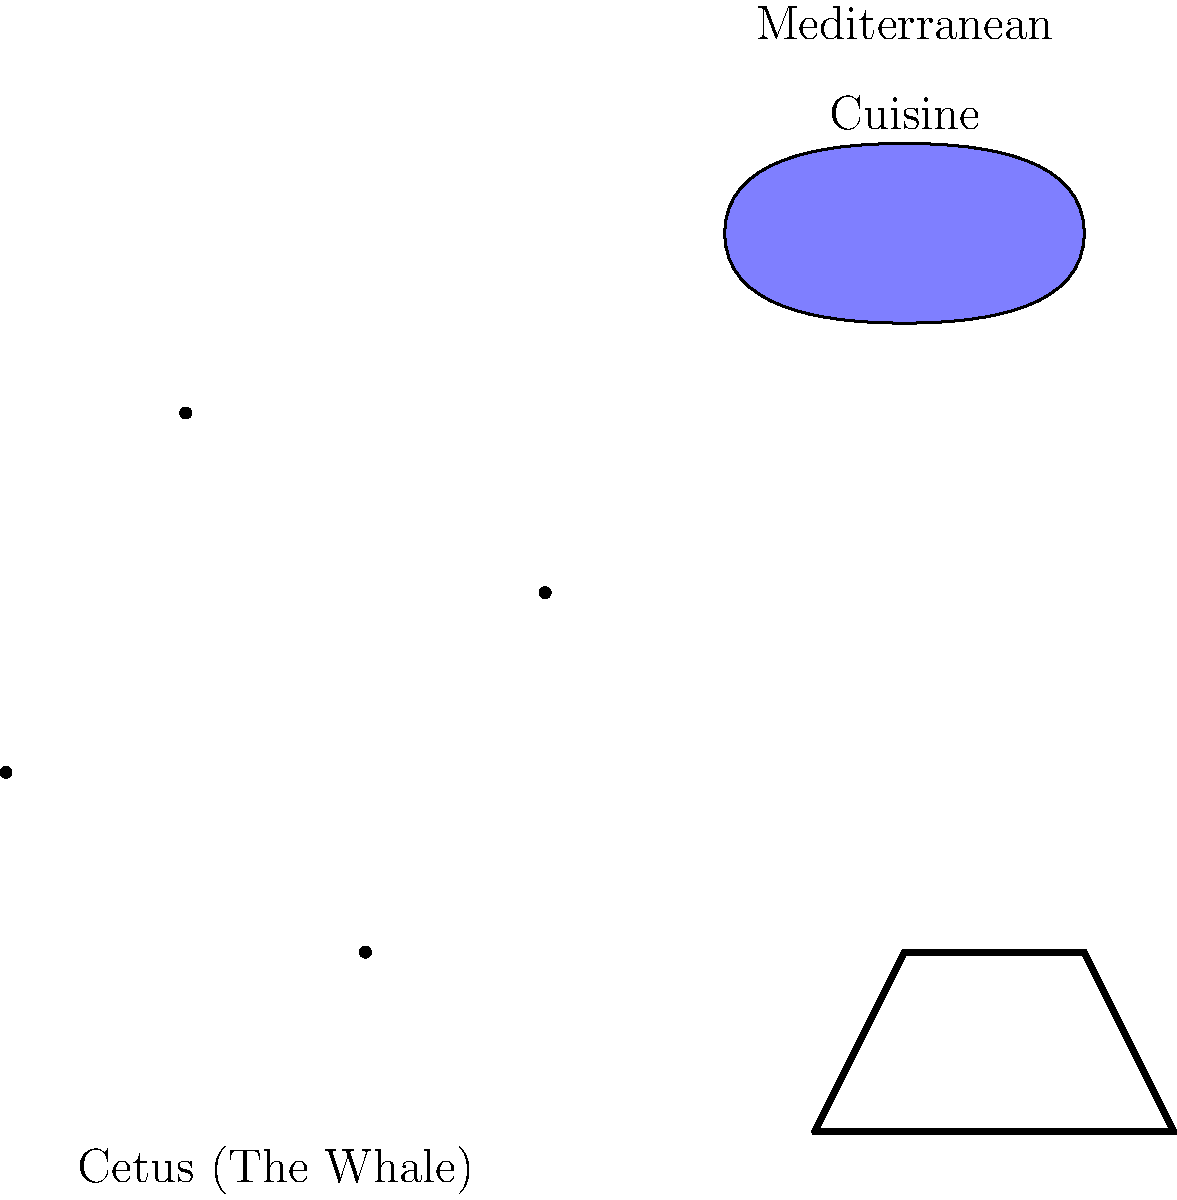Which constellation, associated with Mediterranean cuisine and often depicted alongside fish symbols, is shown in the image, and what culinary tradition does it represent? To answer this question, let's break down the information provided in the image:

1. The main constellation shape is labeled as "Cetus (The Whale)".
2. There's a stylized fish drawn near the constellation, which is often associated with Mediterranean cuisine.
3. A cooking pot is also depicted, further emphasizing the culinary connection.
4. The text "Mediterranean Cuisine" is clearly visible in the image.

Cetus, also known as "The Whale" or "The Sea Monster", is a constellation visible in the northern hemisphere. In Greek mythology, Cetus was a sea monster sent by Poseidon to ravage the kingdom of Ethiopia.

The connection between Cetus and Mediterranean cuisine stems from the importance of seafood in this culinary tradition. The Mediterranean diet is renowned for its emphasis on fish and other seafood, which aligns with the oceanic theme of the Cetus constellation.

Moreover, in many Mediterranean cultures, fish have been symbols of abundance, fertility, and good luck. The depiction of a fish alongside Cetus in this image reinforces this cultural and culinary association.

Therefore, the constellation Cetus is being used here to represent the rich maritime heritage and seafood-centric nature of Mediterranean cuisine.
Answer: Cetus; Mediterranean cuisine 